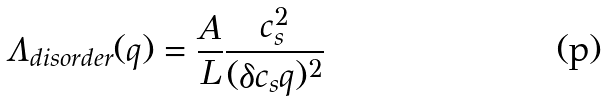<formula> <loc_0><loc_0><loc_500><loc_500>\Lambda _ { d i s o r d e r } ( q ) = \frac { A } { L } \frac { c ^ { 2 } _ { s } } { ( \delta c _ { s } q ) ^ { 2 } }</formula> 